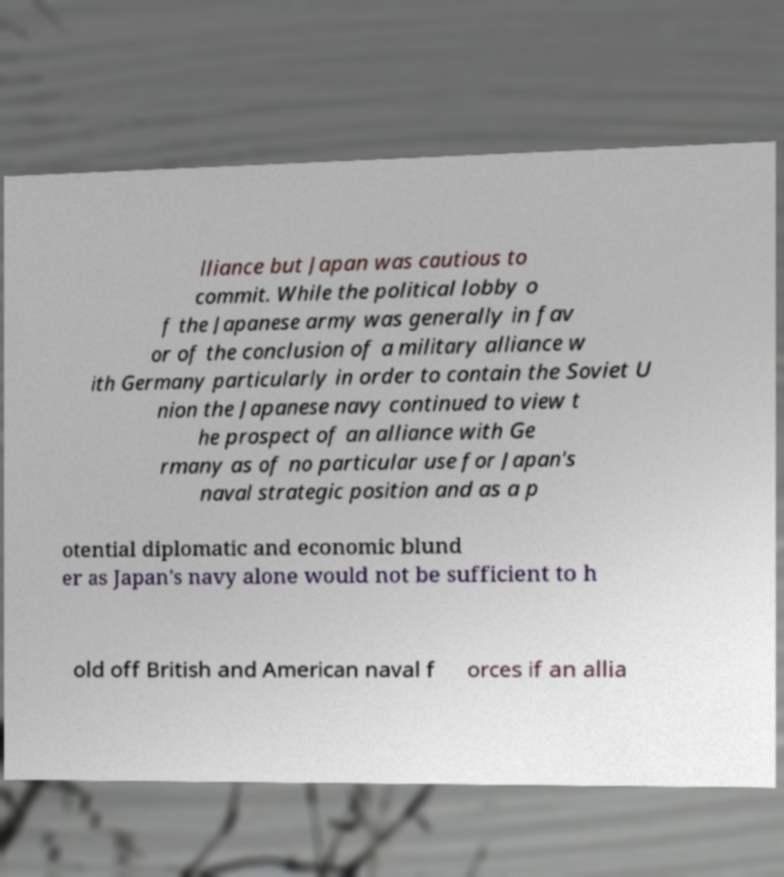Please identify and transcribe the text found in this image. lliance but Japan was cautious to commit. While the political lobby o f the Japanese army was generally in fav or of the conclusion of a military alliance w ith Germany particularly in order to contain the Soviet U nion the Japanese navy continued to view t he prospect of an alliance with Ge rmany as of no particular use for Japan's naval strategic position and as a p otential diplomatic and economic blund er as Japan's navy alone would not be sufficient to h old off British and American naval f orces if an allia 